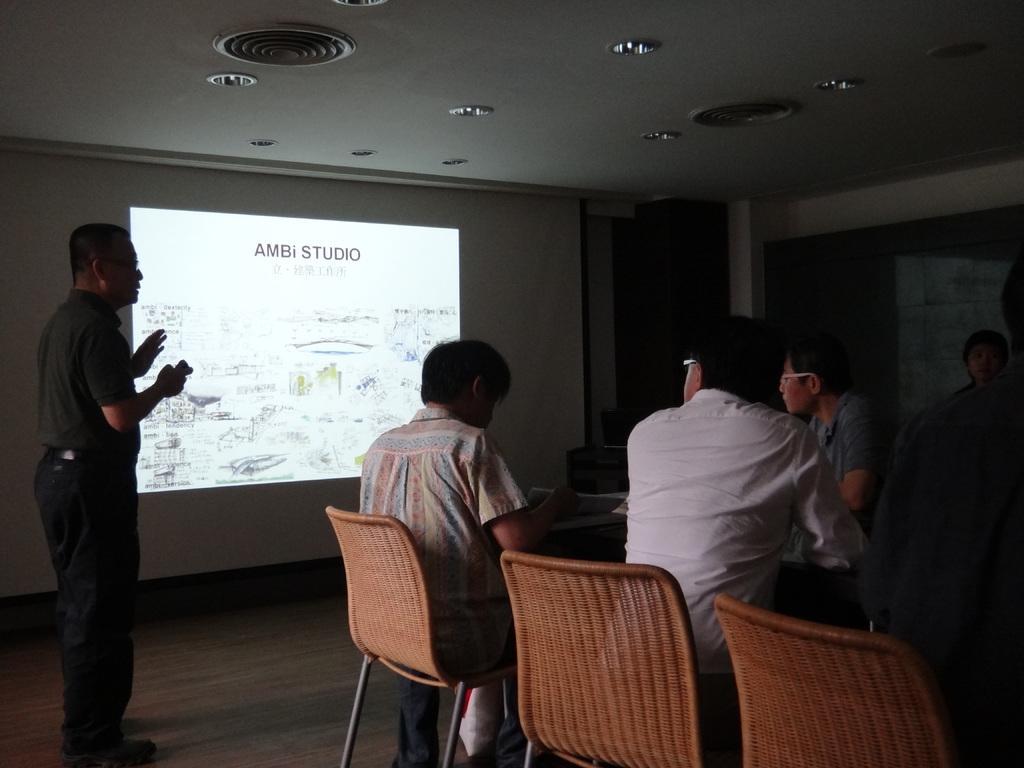Describe this image in one or two sentences. This image is taken in a room. In the middle of this image there is a wall and a projector screen on it with a text. In this room there is a floor. In the left side of the image there is a man standing holding a remote in his hand. In the middle of the room a man sitting on a chair placing his hands on a table. In the right side of a table a man is standing. At the top most in the middle there is a ceiling with lights. 